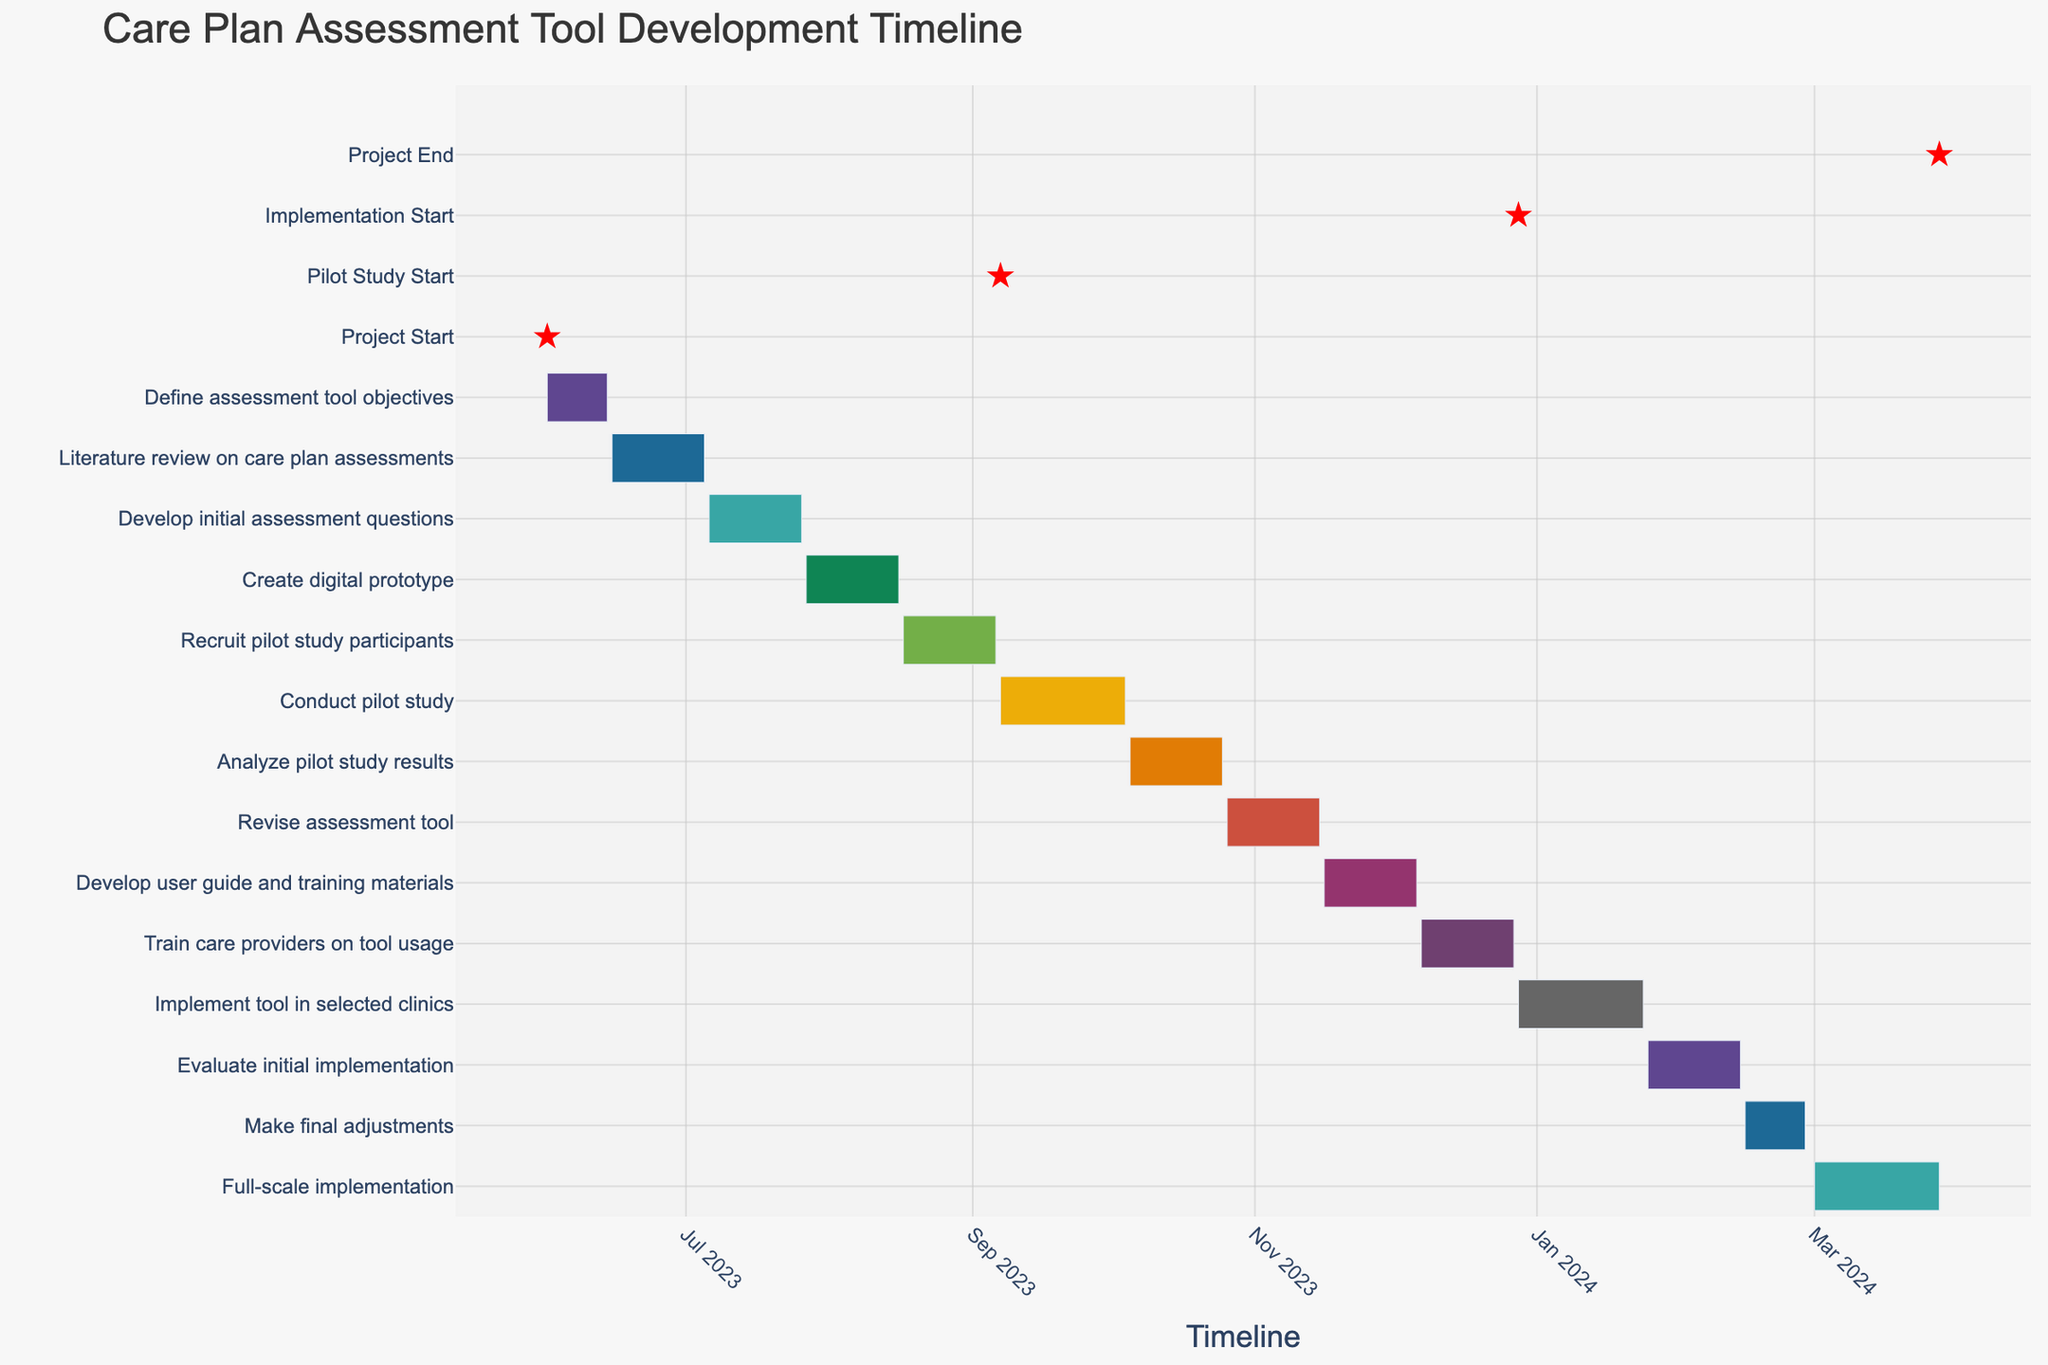How long did the 'Define assessment tool objectives' task take? The 'Define assessment tool objectives' task started on June 1, 2023, and ended on June 14, 2023. The duration was directly given as 14 days.
Answer: 14 days Which tasks were conducted in July 2023? By looking at the Gantt Chart, we can see that the 'Literature review on care plan assessments' (June 15, 2023 - July 5, 2023) and 'Develop initial assessment questions' (July 6, 2023 - July 26, 2023) were conducted in July 2023.
Answer: Literature review on care plan assessments, Develop initial assessment questions Which task had the same duration as 'Analyze pilot study results'? The 'Analyze pilot study results' task (October 5, 2023 - October 25, 2023) had a duration of 21 days. Tasks with the same duration include 'Literature review on care plan assessments,' 'Develop initial assessment questions,' 'Create digital prototype,' 'Recruit pilot study participants,' 'Revise assessment tool,' 'Develop user guide and training materials,' 'Train care providers on tool usage,' and 'Evaluate initial implementation.'
Answer: Literature review on care plan assessments, Develop initial assessment questions, Create digital prototype, Recruit pilot study participants, Revise assessment tool, Develop user guide and training materials, Train care providers on tool usage, Evaluate initial implementation How many tasks have a duration of 28 days? The chart shows 'Conduct pilot study' (September 7, 2023 - October 4, 2023), 'Implement tool in selected clinics' (December 28, 2023 - January 24, 2024), and 'Full-scale implementation' (March 1, 2024 - March 28, 2024) each took 28 days.
Answer: 3 What is the total duration of the project from start to end? The project started on June 1, 2023, and ended on March 28, 2024. We measure the duration between these two dates.
Answer: 10 months and 27 days Which tasks occur simultaneously? The Gantt chart shows there are no tasks that overlap entirely. However, tasks like 'Recruit pilot study participants' (August 17, 2023 - September 6, 2023) and 'Conduct pilot study' (September 7, 2023 - October 4, 2023) follow immediately after one another without gaps.
Answer: None What milestone is marked by the red star in August? The red star in August marks the milestone of recruiting pilot study participants, starting on August 17, 2023.
Answer: Recruit pilot study participants What’s the first milestone after the project start? The first milestone after the project start is the beginning of the pilot study on September 7, 2023.
Answer: Pilot Study Start Which tasks were completed in 2024? Tasks completed in 2024 include 'Evaluate initial implementation' (January 25, 2024 - February 14, 2024), 'Make final adjustments' (February 15, 2024 - February 28, 2024), and 'Full-scale implementation' (March 1, 2024 - March 28, 2024).
Answer: Evaluate initial implementation, Make final adjustments, Full-scale implementation 